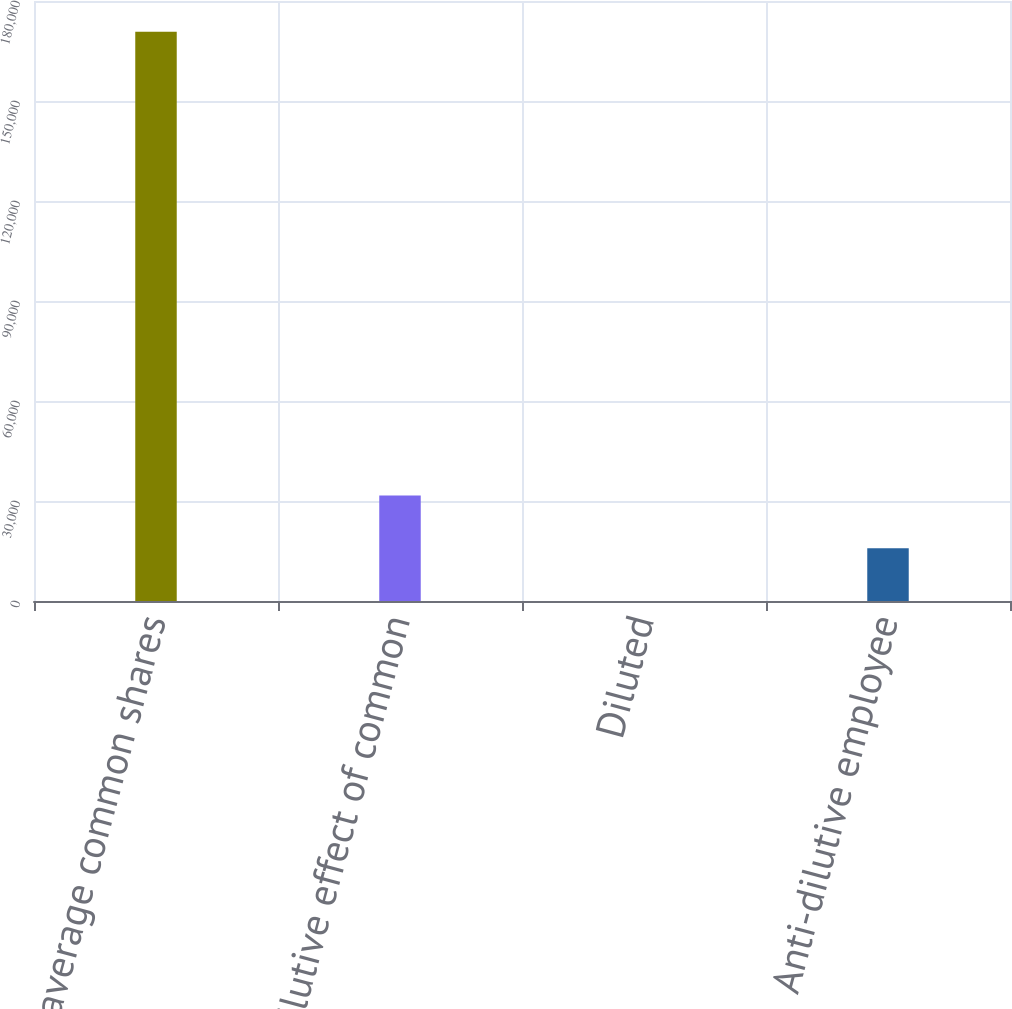Convert chart. <chart><loc_0><loc_0><loc_500><loc_500><bar_chart><fcel>Weighted average common shares<fcel>Dilutive effect of common<fcel>Diluted<fcel>Anti-dilutive employee<nl><fcel>170763<fcel>31614.2<fcel>1.43<fcel>15807.8<nl></chart> 